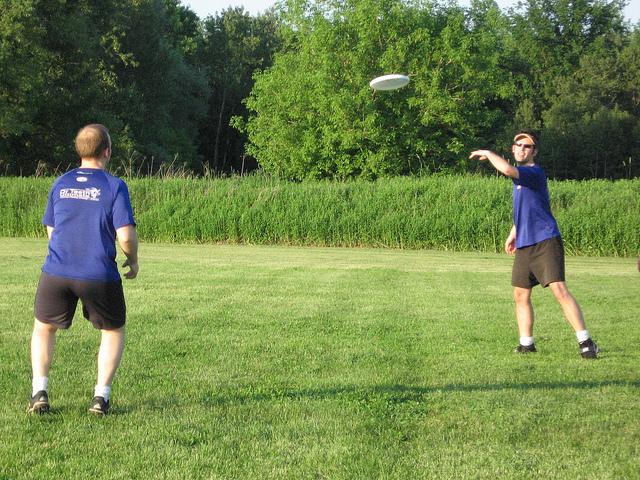Is that a soccer ball they are kicking?
Short answer required. No. Which sport are they playing?
Quick response, please. Frisbee. What game is the boy playing?
Answer briefly. Frisbee. Are these men on a team?
Concise answer only. Yes. What game the guys are playing?
Keep it brief. Frisbee. What sport are the children playing?
Give a very brief answer. Frisbee. What is the player in the blue shirt holding?
Answer briefly. Frisbee. What sport are the boys playing?
Short answer required. Frisbee. Are these men pursuing a healthy activity?
Write a very short answer. Yes. Is this picture slanted?
Write a very short answer. No. Where are they playing frisbee at?
Be succinct. Field. What color are there shirts?
Short answer required. Blue. 